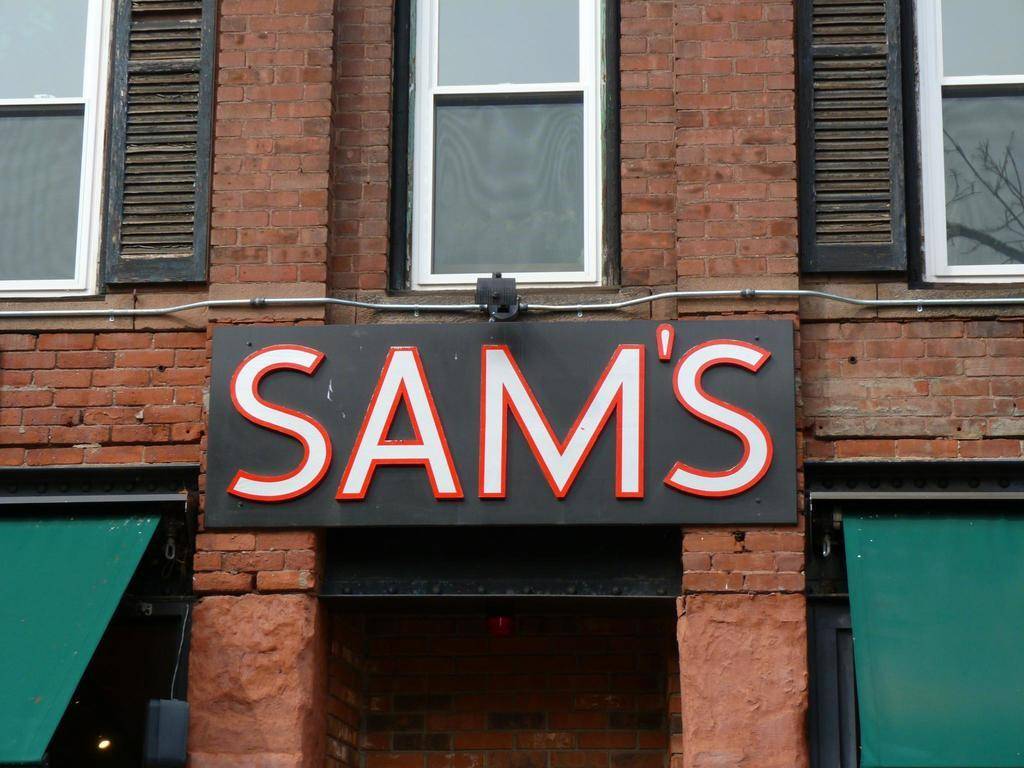<image>
Relay a brief, clear account of the picture shown. Sign stating SAM'S above a doorway between two awnings. 